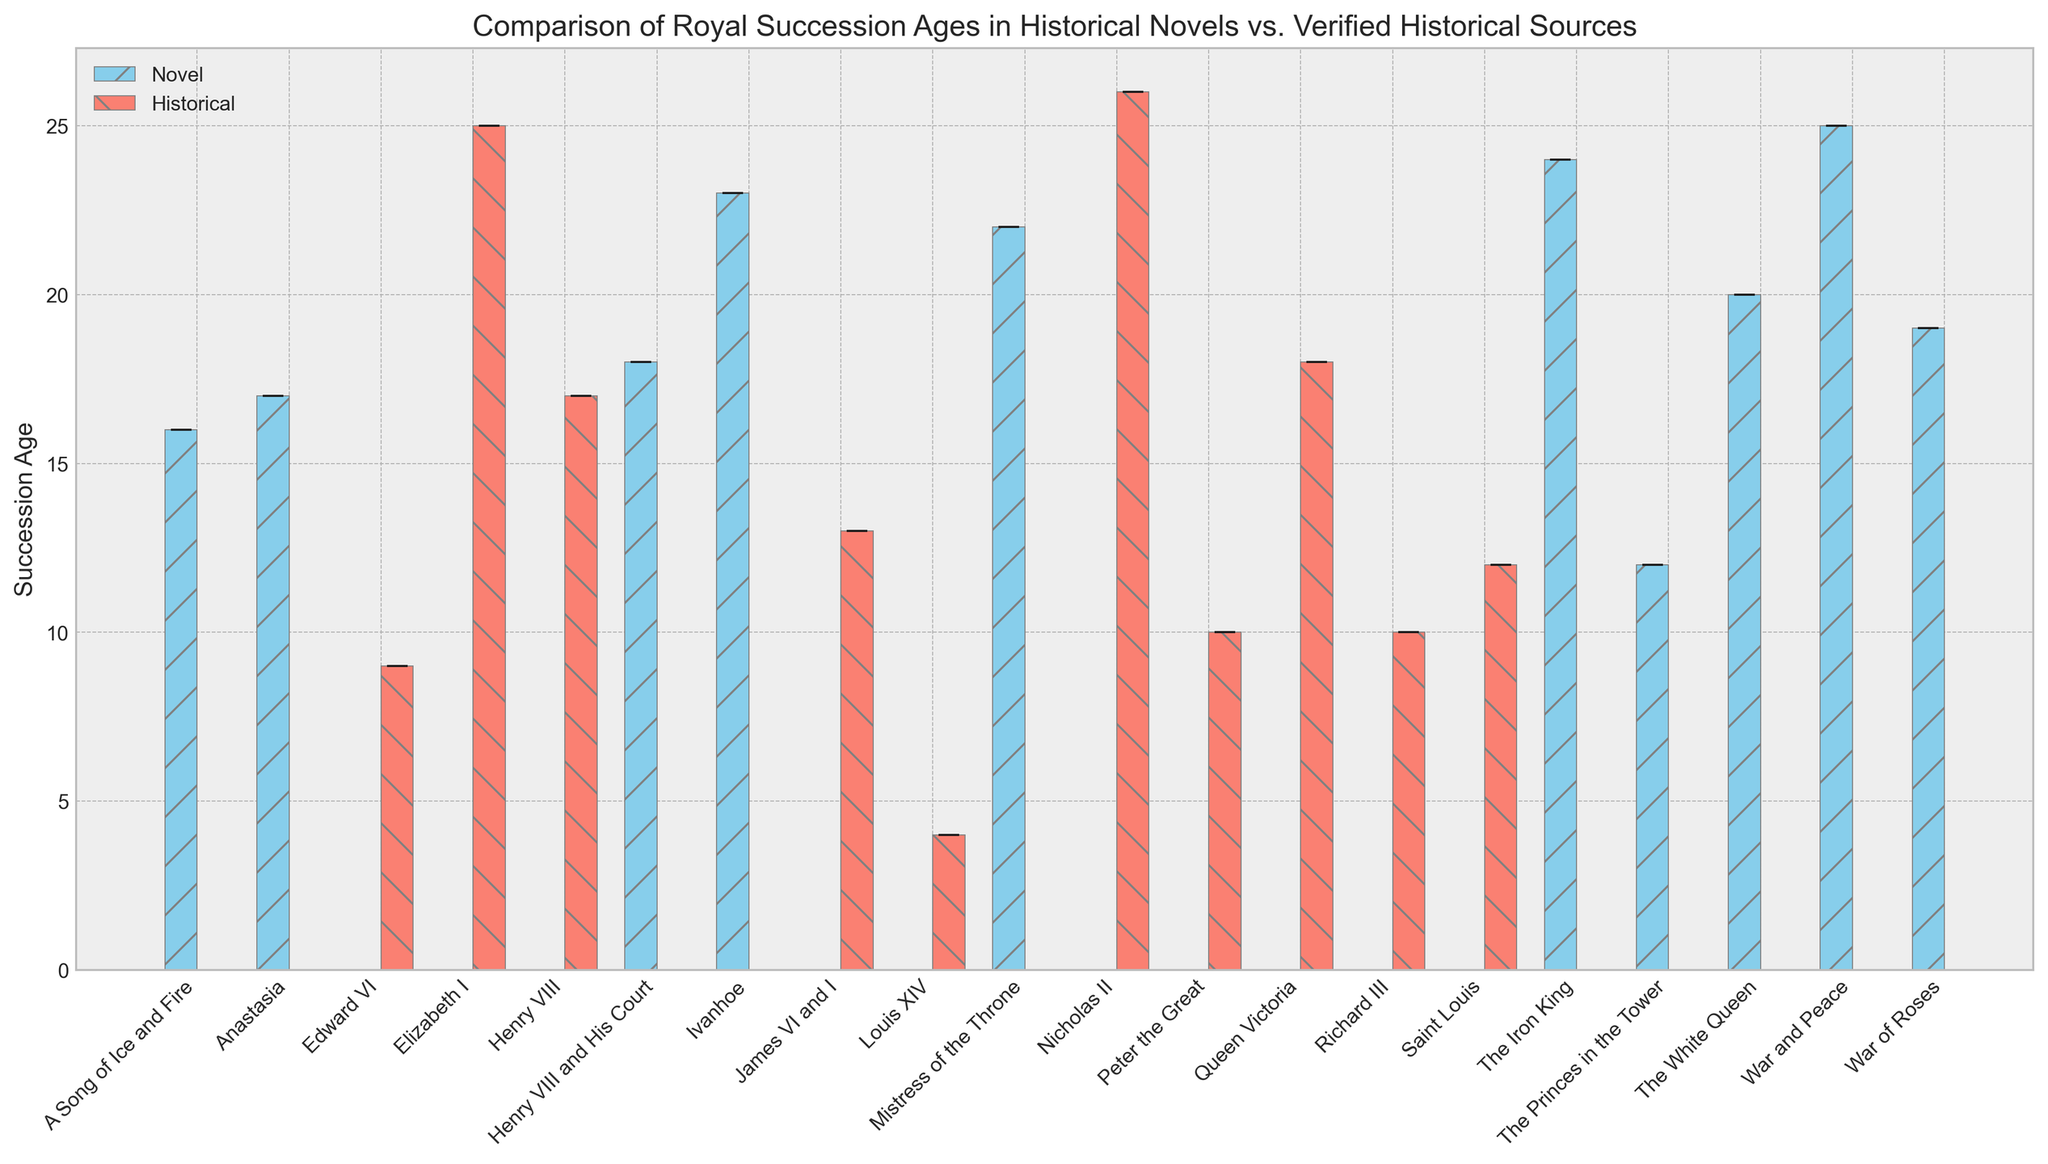what is the most common succession age for verified historical sources? To determine the most common succession age within historical sources, we must observe the red bars labeled "Historical" in the figure. By examining them, it's clear that several bars reach the same height, representing ages where succession frequently happens. Specifically, ages 10 and 12 seem to appear more commonly compared to others.
Answer: 10 and 12 Which historical novel shows the youngest succession age? By looking at the blue bars labeled "Novel" in the figure, it is evident that "The Princes in the Tower" shows the shortest blue bar, representing the youngest succession age among historical novels.
Answer: The Princes in the Tower What is the difference in average age between historical novels and verified historical sources for the title "Henry VIII"? The blue bar for "Henry VIII and His Court" (Novel) shows an age of 18, while the red bar for "Henry VIII" (Historical) shows an age of 17. The difference is obtained by subtracting the two values (18 - 17).
Answer: 1 Which title has the largest discrepancy in succession age between novels and historical sources? By looking for the maximum distance between the heights of blue and red bars for the same title, we can observe that "Louis XIV" in historical sources has a very low age (4), while it is absent in novel data, indicating a large discrepancy exists.
Answer: Louis XIV What's the average and the variance of the succession ages for novels? To calculate the average, sum the ages of all the novels and divide by the number of novels. For variance, compute the squared differences between each age and the mean, and average them. The ages are 25, 23, 12, 18, 16, 19, 22, 24, 17, and 20. The average is (25+23+12+18+16+19+22+24+17+20)/10=19.6. The variance requires calculating the squared differences from the mean and averaging them.
Answer: Average: 19.6, Variance: 15.84 